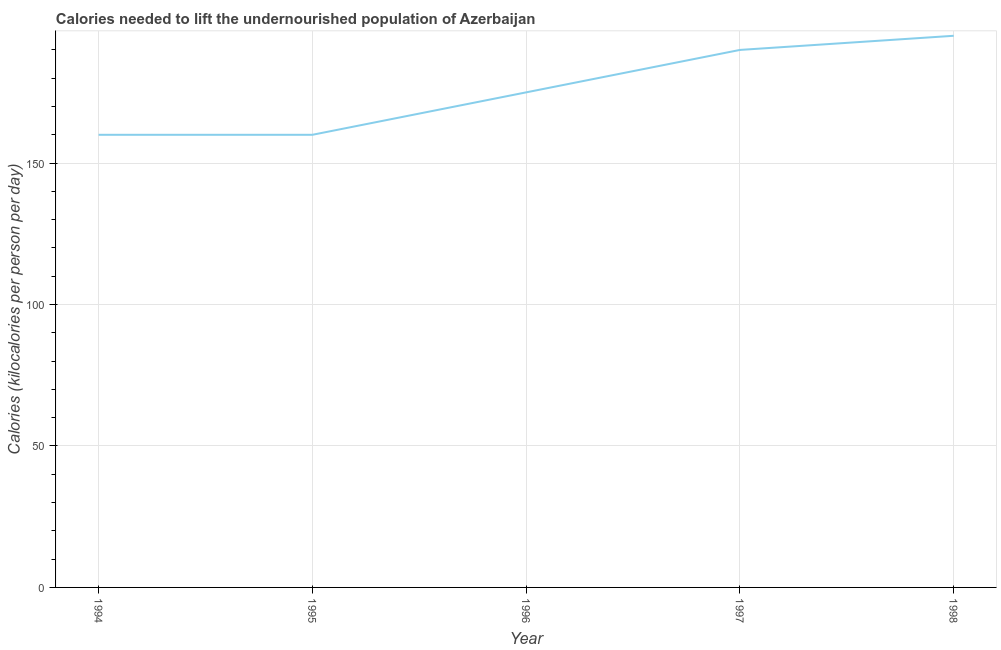What is the depth of food deficit in 1995?
Make the answer very short. 160. Across all years, what is the maximum depth of food deficit?
Provide a succinct answer. 195. Across all years, what is the minimum depth of food deficit?
Your answer should be very brief. 160. In which year was the depth of food deficit maximum?
Offer a terse response. 1998. In which year was the depth of food deficit minimum?
Offer a terse response. 1994. What is the sum of the depth of food deficit?
Offer a very short reply. 880. What is the average depth of food deficit per year?
Your answer should be very brief. 176. What is the median depth of food deficit?
Offer a terse response. 175. Do a majority of the years between 1998 and 1996 (inclusive) have depth of food deficit greater than 150 kilocalories?
Give a very brief answer. No. What is the ratio of the depth of food deficit in 1997 to that in 1998?
Keep it short and to the point. 0.97. Is the depth of food deficit in 1994 less than that in 1997?
Your answer should be compact. Yes. Is the difference between the depth of food deficit in 1994 and 1998 greater than the difference between any two years?
Make the answer very short. Yes. What is the difference between the highest and the lowest depth of food deficit?
Your answer should be very brief. 35. How many years are there in the graph?
Your response must be concise. 5. Are the values on the major ticks of Y-axis written in scientific E-notation?
Make the answer very short. No. Does the graph contain any zero values?
Your answer should be compact. No. What is the title of the graph?
Give a very brief answer. Calories needed to lift the undernourished population of Azerbaijan. What is the label or title of the X-axis?
Your answer should be compact. Year. What is the label or title of the Y-axis?
Your response must be concise. Calories (kilocalories per person per day). What is the Calories (kilocalories per person per day) in 1994?
Provide a succinct answer. 160. What is the Calories (kilocalories per person per day) in 1995?
Provide a succinct answer. 160. What is the Calories (kilocalories per person per day) of 1996?
Give a very brief answer. 175. What is the Calories (kilocalories per person per day) in 1997?
Your answer should be very brief. 190. What is the Calories (kilocalories per person per day) in 1998?
Provide a succinct answer. 195. What is the difference between the Calories (kilocalories per person per day) in 1994 and 1995?
Provide a succinct answer. 0. What is the difference between the Calories (kilocalories per person per day) in 1994 and 1998?
Give a very brief answer. -35. What is the difference between the Calories (kilocalories per person per day) in 1995 and 1996?
Your answer should be very brief. -15. What is the difference between the Calories (kilocalories per person per day) in 1995 and 1998?
Provide a short and direct response. -35. What is the difference between the Calories (kilocalories per person per day) in 1996 and 1997?
Offer a very short reply. -15. What is the ratio of the Calories (kilocalories per person per day) in 1994 to that in 1995?
Your answer should be compact. 1. What is the ratio of the Calories (kilocalories per person per day) in 1994 to that in 1996?
Offer a terse response. 0.91. What is the ratio of the Calories (kilocalories per person per day) in 1994 to that in 1997?
Provide a succinct answer. 0.84. What is the ratio of the Calories (kilocalories per person per day) in 1994 to that in 1998?
Provide a succinct answer. 0.82. What is the ratio of the Calories (kilocalories per person per day) in 1995 to that in 1996?
Keep it short and to the point. 0.91. What is the ratio of the Calories (kilocalories per person per day) in 1995 to that in 1997?
Your response must be concise. 0.84. What is the ratio of the Calories (kilocalories per person per day) in 1995 to that in 1998?
Give a very brief answer. 0.82. What is the ratio of the Calories (kilocalories per person per day) in 1996 to that in 1997?
Offer a very short reply. 0.92. What is the ratio of the Calories (kilocalories per person per day) in 1996 to that in 1998?
Your answer should be very brief. 0.9. 